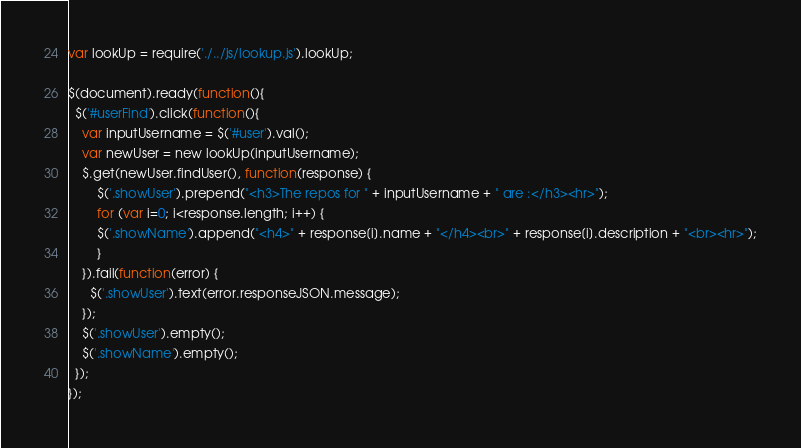Convert code to text. <code><loc_0><loc_0><loc_500><loc_500><_JavaScript_>var lookUp = require('./../js/lookup.js').lookUp;

$(document).ready(function(){
  $('#userFind').click(function(){
    var inputUsername = $('#user').val();
    var newUser = new lookUp(inputUsername);
    $.get(newUser.findUser(), function(response) {
    	$('.showUser').prepend("<h3>The repos for " + inputUsername + " are :</h3><hr>");
    	for (var i=0; i<response.length; i++) {
        $('.showName').append("<h4>" + response[i].name + "</h4><br>" + response[i].description + "<br><hr>");
	    }
    }).fail(function(error) {
      $('.showUser').text(error.responseJSON.message);
    });
    $('.showUser').empty();
    $('.showName').empty();
  });
});</code> 